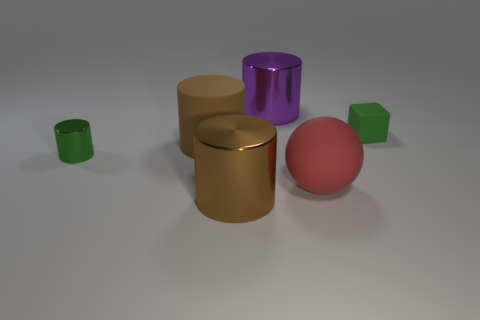Subtract all cyan cylinders. Subtract all brown spheres. How many cylinders are left? 4 Add 2 small gray shiny things. How many objects exist? 8 Subtract all cylinders. How many objects are left? 2 Add 2 green objects. How many green objects exist? 4 Subtract 1 green blocks. How many objects are left? 5 Subtract all small cubes. Subtract all red objects. How many objects are left? 4 Add 6 large red balls. How many large red balls are left? 7 